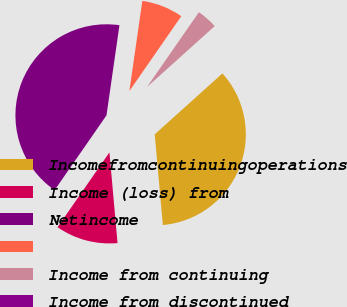Convert chart. <chart><loc_0><loc_0><loc_500><loc_500><pie_chart><fcel>Incomefromcontinuingoperations<fcel>Income (loss) from<fcel>Netincome<fcel>Unnamed: 3<fcel>Income from continuing<fcel>Income from discontinued<nl><fcel>35.24%<fcel>11.07%<fcel>42.62%<fcel>7.38%<fcel>3.69%<fcel>0.0%<nl></chart> 